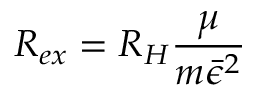<formula> <loc_0><loc_0><loc_500><loc_500>R _ { e x } = R _ { H } \frac { \mu } { m \bar { \epsilon } ^ { 2 } }</formula> 